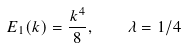<formula> <loc_0><loc_0><loc_500><loc_500>E _ { 1 } ( k ) = \frac { k ^ { 4 } } { 8 } , \quad \lambda = 1 / 4</formula> 